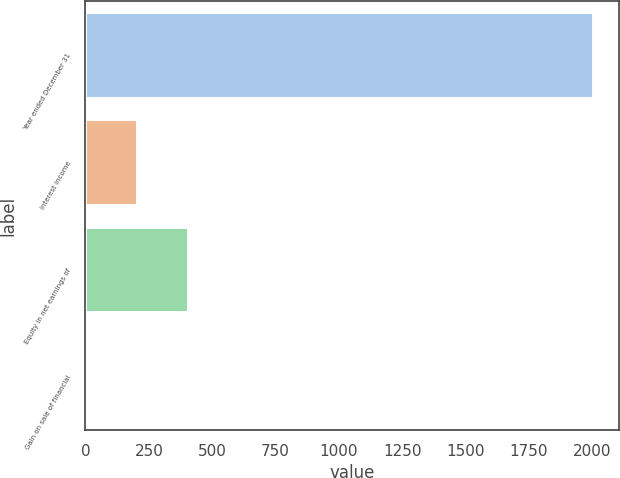<chart> <loc_0><loc_0><loc_500><loc_500><bar_chart><fcel>Year ended December 31<fcel>Interest income<fcel>Equity in net earnings of<fcel>Gain on sale of financial<nl><fcel>2003<fcel>204.8<fcel>404.6<fcel>5<nl></chart> 